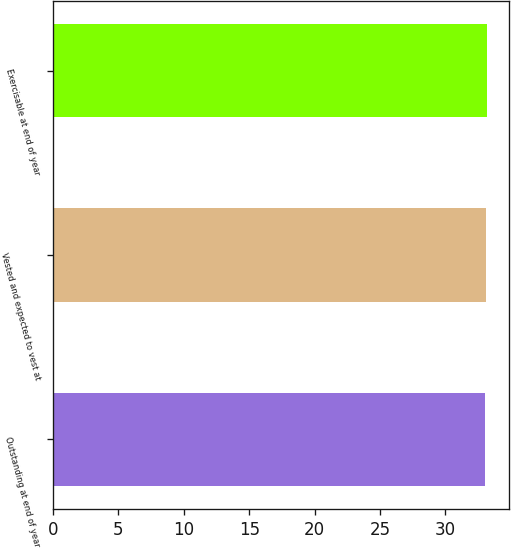Convert chart. <chart><loc_0><loc_0><loc_500><loc_500><bar_chart><fcel>Outstanding at end of year<fcel>Vested and expected to vest at<fcel>Exercisable at end of year<nl><fcel>33<fcel>33.1<fcel>33.2<nl></chart> 